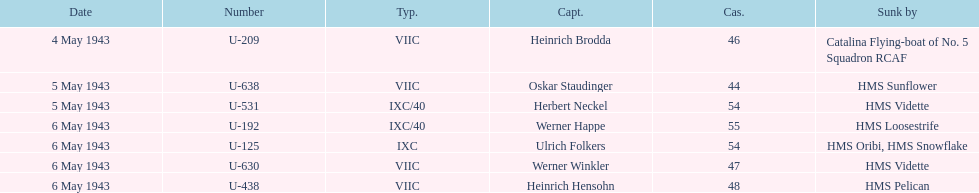What was the number of casualties on may 4 1943? 46. 